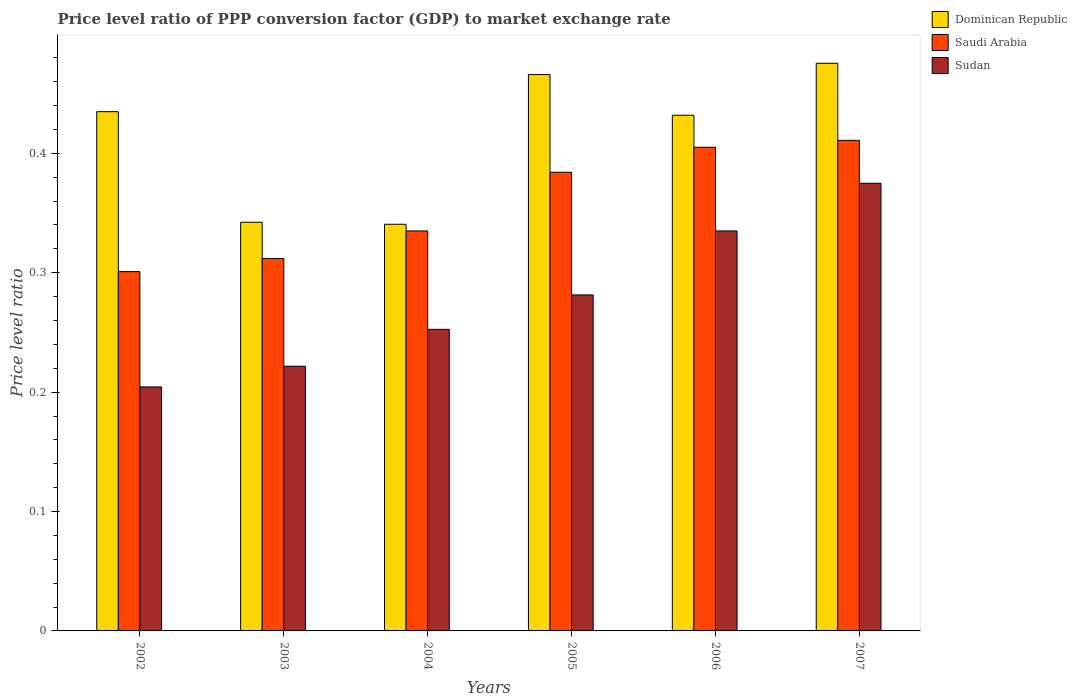How many different coloured bars are there?
Offer a very short reply. 3. Are the number of bars per tick equal to the number of legend labels?
Make the answer very short. Yes. How many bars are there on the 4th tick from the left?
Offer a very short reply. 3. In how many cases, is the number of bars for a given year not equal to the number of legend labels?
Offer a terse response. 0. What is the price level ratio in Saudi Arabia in 2002?
Provide a succinct answer. 0.3. Across all years, what is the maximum price level ratio in Sudan?
Provide a succinct answer. 0.37. Across all years, what is the minimum price level ratio in Saudi Arabia?
Offer a very short reply. 0.3. In which year was the price level ratio in Saudi Arabia maximum?
Your answer should be very brief. 2007. What is the total price level ratio in Dominican Republic in the graph?
Ensure brevity in your answer.  2.49. What is the difference between the price level ratio in Sudan in 2002 and that in 2007?
Offer a very short reply. -0.17. What is the difference between the price level ratio in Saudi Arabia in 2003 and the price level ratio in Sudan in 2006?
Provide a short and direct response. -0.02. What is the average price level ratio in Dominican Republic per year?
Offer a very short reply. 0.42. In the year 2006, what is the difference between the price level ratio in Sudan and price level ratio in Dominican Republic?
Keep it short and to the point. -0.1. In how many years, is the price level ratio in Sudan greater than 0.2?
Your answer should be very brief. 6. What is the ratio of the price level ratio in Sudan in 2005 to that in 2006?
Make the answer very short. 0.84. Is the price level ratio in Saudi Arabia in 2003 less than that in 2006?
Keep it short and to the point. Yes. Is the difference between the price level ratio in Sudan in 2002 and 2005 greater than the difference between the price level ratio in Dominican Republic in 2002 and 2005?
Make the answer very short. No. What is the difference between the highest and the second highest price level ratio in Dominican Republic?
Offer a very short reply. 0.01. What is the difference between the highest and the lowest price level ratio in Saudi Arabia?
Offer a very short reply. 0.11. In how many years, is the price level ratio in Dominican Republic greater than the average price level ratio in Dominican Republic taken over all years?
Ensure brevity in your answer.  4. Is the sum of the price level ratio in Dominican Republic in 2004 and 2005 greater than the maximum price level ratio in Sudan across all years?
Make the answer very short. Yes. What does the 2nd bar from the left in 2003 represents?
Provide a short and direct response. Saudi Arabia. What does the 2nd bar from the right in 2006 represents?
Provide a succinct answer. Saudi Arabia. How many bars are there?
Provide a short and direct response. 18. Are all the bars in the graph horizontal?
Offer a terse response. No. How many years are there in the graph?
Your answer should be very brief. 6. What is the difference between two consecutive major ticks on the Y-axis?
Provide a short and direct response. 0.1. Does the graph contain any zero values?
Provide a succinct answer. No. Does the graph contain grids?
Your answer should be compact. No. Where does the legend appear in the graph?
Provide a succinct answer. Top right. What is the title of the graph?
Provide a succinct answer. Price level ratio of PPP conversion factor (GDP) to market exchange rate. Does "Hong Kong" appear as one of the legend labels in the graph?
Make the answer very short. No. What is the label or title of the Y-axis?
Keep it short and to the point. Price level ratio. What is the Price level ratio in Dominican Republic in 2002?
Offer a terse response. 0.43. What is the Price level ratio of Saudi Arabia in 2002?
Provide a short and direct response. 0.3. What is the Price level ratio in Sudan in 2002?
Your response must be concise. 0.2. What is the Price level ratio of Dominican Republic in 2003?
Offer a terse response. 0.34. What is the Price level ratio in Saudi Arabia in 2003?
Provide a succinct answer. 0.31. What is the Price level ratio in Sudan in 2003?
Keep it short and to the point. 0.22. What is the Price level ratio in Dominican Republic in 2004?
Make the answer very short. 0.34. What is the Price level ratio of Saudi Arabia in 2004?
Your answer should be very brief. 0.34. What is the Price level ratio of Sudan in 2004?
Offer a very short reply. 0.25. What is the Price level ratio of Dominican Republic in 2005?
Give a very brief answer. 0.47. What is the Price level ratio of Saudi Arabia in 2005?
Provide a succinct answer. 0.38. What is the Price level ratio of Sudan in 2005?
Provide a short and direct response. 0.28. What is the Price level ratio in Dominican Republic in 2006?
Make the answer very short. 0.43. What is the Price level ratio in Saudi Arabia in 2006?
Give a very brief answer. 0.41. What is the Price level ratio in Sudan in 2006?
Offer a terse response. 0.34. What is the Price level ratio of Dominican Republic in 2007?
Offer a terse response. 0.48. What is the Price level ratio of Saudi Arabia in 2007?
Provide a succinct answer. 0.41. What is the Price level ratio in Sudan in 2007?
Offer a terse response. 0.37. Across all years, what is the maximum Price level ratio in Dominican Republic?
Ensure brevity in your answer.  0.48. Across all years, what is the maximum Price level ratio of Saudi Arabia?
Make the answer very short. 0.41. Across all years, what is the maximum Price level ratio of Sudan?
Provide a short and direct response. 0.37. Across all years, what is the minimum Price level ratio in Dominican Republic?
Your response must be concise. 0.34. Across all years, what is the minimum Price level ratio in Saudi Arabia?
Keep it short and to the point. 0.3. Across all years, what is the minimum Price level ratio in Sudan?
Your answer should be compact. 0.2. What is the total Price level ratio of Dominican Republic in the graph?
Provide a succinct answer. 2.49. What is the total Price level ratio in Saudi Arabia in the graph?
Provide a succinct answer. 2.15. What is the total Price level ratio of Sudan in the graph?
Offer a terse response. 1.67. What is the difference between the Price level ratio of Dominican Republic in 2002 and that in 2003?
Your answer should be compact. 0.09. What is the difference between the Price level ratio in Saudi Arabia in 2002 and that in 2003?
Offer a terse response. -0.01. What is the difference between the Price level ratio of Sudan in 2002 and that in 2003?
Your answer should be compact. -0.02. What is the difference between the Price level ratio of Dominican Republic in 2002 and that in 2004?
Give a very brief answer. 0.09. What is the difference between the Price level ratio of Saudi Arabia in 2002 and that in 2004?
Your answer should be compact. -0.03. What is the difference between the Price level ratio in Sudan in 2002 and that in 2004?
Keep it short and to the point. -0.05. What is the difference between the Price level ratio of Dominican Republic in 2002 and that in 2005?
Offer a terse response. -0.03. What is the difference between the Price level ratio of Saudi Arabia in 2002 and that in 2005?
Your response must be concise. -0.08. What is the difference between the Price level ratio of Sudan in 2002 and that in 2005?
Offer a terse response. -0.08. What is the difference between the Price level ratio of Dominican Republic in 2002 and that in 2006?
Give a very brief answer. 0. What is the difference between the Price level ratio in Saudi Arabia in 2002 and that in 2006?
Your answer should be compact. -0.1. What is the difference between the Price level ratio of Sudan in 2002 and that in 2006?
Your answer should be very brief. -0.13. What is the difference between the Price level ratio of Dominican Republic in 2002 and that in 2007?
Keep it short and to the point. -0.04. What is the difference between the Price level ratio in Saudi Arabia in 2002 and that in 2007?
Ensure brevity in your answer.  -0.11. What is the difference between the Price level ratio in Sudan in 2002 and that in 2007?
Offer a very short reply. -0.17. What is the difference between the Price level ratio in Dominican Republic in 2003 and that in 2004?
Your answer should be compact. 0. What is the difference between the Price level ratio of Saudi Arabia in 2003 and that in 2004?
Give a very brief answer. -0.02. What is the difference between the Price level ratio in Sudan in 2003 and that in 2004?
Make the answer very short. -0.03. What is the difference between the Price level ratio in Dominican Republic in 2003 and that in 2005?
Give a very brief answer. -0.12. What is the difference between the Price level ratio of Saudi Arabia in 2003 and that in 2005?
Provide a short and direct response. -0.07. What is the difference between the Price level ratio in Sudan in 2003 and that in 2005?
Give a very brief answer. -0.06. What is the difference between the Price level ratio of Dominican Republic in 2003 and that in 2006?
Your answer should be very brief. -0.09. What is the difference between the Price level ratio in Saudi Arabia in 2003 and that in 2006?
Your response must be concise. -0.09. What is the difference between the Price level ratio of Sudan in 2003 and that in 2006?
Provide a short and direct response. -0.11. What is the difference between the Price level ratio in Dominican Republic in 2003 and that in 2007?
Make the answer very short. -0.13. What is the difference between the Price level ratio in Saudi Arabia in 2003 and that in 2007?
Your answer should be compact. -0.1. What is the difference between the Price level ratio of Sudan in 2003 and that in 2007?
Offer a very short reply. -0.15. What is the difference between the Price level ratio in Dominican Republic in 2004 and that in 2005?
Your response must be concise. -0.13. What is the difference between the Price level ratio in Saudi Arabia in 2004 and that in 2005?
Provide a short and direct response. -0.05. What is the difference between the Price level ratio in Sudan in 2004 and that in 2005?
Keep it short and to the point. -0.03. What is the difference between the Price level ratio in Dominican Republic in 2004 and that in 2006?
Give a very brief answer. -0.09. What is the difference between the Price level ratio of Saudi Arabia in 2004 and that in 2006?
Ensure brevity in your answer.  -0.07. What is the difference between the Price level ratio of Sudan in 2004 and that in 2006?
Give a very brief answer. -0.08. What is the difference between the Price level ratio of Dominican Republic in 2004 and that in 2007?
Offer a very short reply. -0.13. What is the difference between the Price level ratio of Saudi Arabia in 2004 and that in 2007?
Provide a short and direct response. -0.08. What is the difference between the Price level ratio in Sudan in 2004 and that in 2007?
Your answer should be very brief. -0.12. What is the difference between the Price level ratio in Dominican Republic in 2005 and that in 2006?
Ensure brevity in your answer.  0.03. What is the difference between the Price level ratio of Saudi Arabia in 2005 and that in 2006?
Your response must be concise. -0.02. What is the difference between the Price level ratio in Sudan in 2005 and that in 2006?
Your answer should be very brief. -0.05. What is the difference between the Price level ratio in Dominican Republic in 2005 and that in 2007?
Offer a very short reply. -0.01. What is the difference between the Price level ratio of Saudi Arabia in 2005 and that in 2007?
Your response must be concise. -0.03. What is the difference between the Price level ratio of Sudan in 2005 and that in 2007?
Give a very brief answer. -0.09. What is the difference between the Price level ratio of Dominican Republic in 2006 and that in 2007?
Make the answer very short. -0.04. What is the difference between the Price level ratio in Saudi Arabia in 2006 and that in 2007?
Keep it short and to the point. -0.01. What is the difference between the Price level ratio of Sudan in 2006 and that in 2007?
Your answer should be very brief. -0.04. What is the difference between the Price level ratio in Dominican Republic in 2002 and the Price level ratio in Saudi Arabia in 2003?
Your response must be concise. 0.12. What is the difference between the Price level ratio in Dominican Republic in 2002 and the Price level ratio in Sudan in 2003?
Keep it short and to the point. 0.21. What is the difference between the Price level ratio in Saudi Arabia in 2002 and the Price level ratio in Sudan in 2003?
Your answer should be compact. 0.08. What is the difference between the Price level ratio in Dominican Republic in 2002 and the Price level ratio in Saudi Arabia in 2004?
Your answer should be compact. 0.1. What is the difference between the Price level ratio in Dominican Republic in 2002 and the Price level ratio in Sudan in 2004?
Provide a short and direct response. 0.18. What is the difference between the Price level ratio in Saudi Arabia in 2002 and the Price level ratio in Sudan in 2004?
Offer a very short reply. 0.05. What is the difference between the Price level ratio of Dominican Republic in 2002 and the Price level ratio of Saudi Arabia in 2005?
Give a very brief answer. 0.05. What is the difference between the Price level ratio in Dominican Republic in 2002 and the Price level ratio in Sudan in 2005?
Ensure brevity in your answer.  0.15. What is the difference between the Price level ratio of Saudi Arabia in 2002 and the Price level ratio of Sudan in 2005?
Make the answer very short. 0.02. What is the difference between the Price level ratio of Dominican Republic in 2002 and the Price level ratio of Saudi Arabia in 2006?
Your answer should be very brief. 0.03. What is the difference between the Price level ratio in Dominican Republic in 2002 and the Price level ratio in Sudan in 2006?
Ensure brevity in your answer.  0.1. What is the difference between the Price level ratio of Saudi Arabia in 2002 and the Price level ratio of Sudan in 2006?
Your response must be concise. -0.03. What is the difference between the Price level ratio in Dominican Republic in 2002 and the Price level ratio in Saudi Arabia in 2007?
Your answer should be very brief. 0.02. What is the difference between the Price level ratio in Saudi Arabia in 2002 and the Price level ratio in Sudan in 2007?
Offer a very short reply. -0.07. What is the difference between the Price level ratio of Dominican Republic in 2003 and the Price level ratio of Saudi Arabia in 2004?
Keep it short and to the point. 0.01. What is the difference between the Price level ratio in Dominican Republic in 2003 and the Price level ratio in Sudan in 2004?
Provide a short and direct response. 0.09. What is the difference between the Price level ratio in Saudi Arabia in 2003 and the Price level ratio in Sudan in 2004?
Ensure brevity in your answer.  0.06. What is the difference between the Price level ratio of Dominican Republic in 2003 and the Price level ratio of Saudi Arabia in 2005?
Provide a short and direct response. -0.04. What is the difference between the Price level ratio in Dominican Republic in 2003 and the Price level ratio in Sudan in 2005?
Make the answer very short. 0.06. What is the difference between the Price level ratio of Saudi Arabia in 2003 and the Price level ratio of Sudan in 2005?
Keep it short and to the point. 0.03. What is the difference between the Price level ratio in Dominican Republic in 2003 and the Price level ratio in Saudi Arabia in 2006?
Make the answer very short. -0.06. What is the difference between the Price level ratio of Dominican Republic in 2003 and the Price level ratio of Sudan in 2006?
Provide a succinct answer. 0.01. What is the difference between the Price level ratio in Saudi Arabia in 2003 and the Price level ratio in Sudan in 2006?
Provide a succinct answer. -0.02. What is the difference between the Price level ratio in Dominican Republic in 2003 and the Price level ratio in Saudi Arabia in 2007?
Ensure brevity in your answer.  -0.07. What is the difference between the Price level ratio of Dominican Republic in 2003 and the Price level ratio of Sudan in 2007?
Your answer should be very brief. -0.03. What is the difference between the Price level ratio of Saudi Arabia in 2003 and the Price level ratio of Sudan in 2007?
Make the answer very short. -0.06. What is the difference between the Price level ratio in Dominican Republic in 2004 and the Price level ratio in Saudi Arabia in 2005?
Provide a succinct answer. -0.04. What is the difference between the Price level ratio in Dominican Republic in 2004 and the Price level ratio in Sudan in 2005?
Your answer should be compact. 0.06. What is the difference between the Price level ratio in Saudi Arabia in 2004 and the Price level ratio in Sudan in 2005?
Offer a very short reply. 0.05. What is the difference between the Price level ratio in Dominican Republic in 2004 and the Price level ratio in Saudi Arabia in 2006?
Give a very brief answer. -0.06. What is the difference between the Price level ratio in Dominican Republic in 2004 and the Price level ratio in Sudan in 2006?
Your response must be concise. 0.01. What is the difference between the Price level ratio of Saudi Arabia in 2004 and the Price level ratio of Sudan in 2006?
Keep it short and to the point. 0. What is the difference between the Price level ratio in Dominican Republic in 2004 and the Price level ratio in Saudi Arabia in 2007?
Offer a very short reply. -0.07. What is the difference between the Price level ratio in Dominican Republic in 2004 and the Price level ratio in Sudan in 2007?
Your answer should be very brief. -0.03. What is the difference between the Price level ratio of Saudi Arabia in 2004 and the Price level ratio of Sudan in 2007?
Provide a succinct answer. -0.04. What is the difference between the Price level ratio in Dominican Republic in 2005 and the Price level ratio in Saudi Arabia in 2006?
Make the answer very short. 0.06. What is the difference between the Price level ratio in Dominican Republic in 2005 and the Price level ratio in Sudan in 2006?
Provide a succinct answer. 0.13. What is the difference between the Price level ratio in Saudi Arabia in 2005 and the Price level ratio in Sudan in 2006?
Give a very brief answer. 0.05. What is the difference between the Price level ratio in Dominican Republic in 2005 and the Price level ratio in Saudi Arabia in 2007?
Your answer should be compact. 0.06. What is the difference between the Price level ratio in Dominican Republic in 2005 and the Price level ratio in Sudan in 2007?
Offer a very short reply. 0.09. What is the difference between the Price level ratio in Saudi Arabia in 2005 and the Price level ratio in Sudan in 2007?
Your answer should be compact. 0.01. What is the difference between the Price level ratio of Dominican Republic in 2006 and the Price level ratio of Saudi Arabia in 2007?
Your answer should be compact. 0.02. What is the difference between the Price level ratio of Dominican Republic in 2006 and the Price level ratio of Sudan in 2007?
Your answer should be compact. 0.06. What is the difference between the Price level ratio of Saudi Arabia in 2006 and the Price level ratio of Sudan in 2007?
Provide a succinct answer. 0.03. What is the average Price level ratio of Dominican Republic per year?
Your answer should be compact. 0.42. What is the average Price level ratio of Saudi Arabia per year?
Ensure brevity in your answer.  0.36. What is the average Price level ratio in Sudan per year?
Give a very brief answer. 0.28. In the year 2002, what is the difference between the Price level ratio of Dominican Republic and Price level ratio of Saudi Arabia?
Make the answer very short. 0.13. In the year 2002, what is the difference between the Price level ratio in Dominican Republic and Price level ratio in Sudan?
Your answer should be very brief. 0.23. In the year 2002, what is the difference between the Price level ratio of Saudi Arabia and Price level ratio of Sudan?
Give a very brief answer. 0.1. In the year 2003, what is the difference between the Price level ratio of Dominican Republic and Price level ratio of Saudi Arabia?
Offer a terse response. 0.03. In the year 2003, what is the difference between the Price level ratio in Dominican Republic and Price level ratio in Sudan?
Keep it short and to the point. 0.12. In the year 2003, what is the difference between the Price level ratio of Saudi Arabia and Price level ratio of Sudan?
Keep it short and to the point. 0.09. In the year 2004, what is the difference between the Price level ratio of Dominican Republic and Price level ratio of Saudi Arabia?
Your answer should be compact. 0.01. In the year 2004, what is the difference between the Price level ratio in Dominican Republic and Price level ratio in Sudan?
Ensure brevity in your answer.  0.09. In the year 2004, what is the difference between the Price level ratio of Saudi Arabia and Price level ratio of Sudan?
Provide a short and direct response. 0.08. In the year 2005, what is the difference between the Price level ratio of Dominican Republic and Price level ratio of Saudi Arabia?
Offer a very short reply. 0.08. In the year 2005, what is the difference between the Price level ratio in Dominican Republic and Price level ratio in Sudan?
Provide a succinct answer. 0.18. In the year 2005, what is the difference between the Price level ratio of Saudi Arabia and Price level ratio of Sudan?
Offer a very short reply. 0.1. In the year 2006, what is the difference between the Price level ratio of Dominican Republic and Price level ratio of Saudi Arabia?
Offer a very short reply. 0.03. In the year 2006, what is the difference between the Price level ratio of Dominican Republic and Price level ratio of Sudan?
Provide a short and direct response. 0.1. In the year 2006, what is the difference between the Price level ratio in Saudi Arabia and Price level ratio in Sudan?
Ensure brevity in your answer.  0.07. In the year 2007, what is the difference between the Price level ratio in Dominican Republic and Price level ratio in Saudi Arabia?
Make the answer very short. 0.06. In the year 2007, what is the difference between the Price level ratio of Dominican Republic and Price level ratio of Sudan?
Your response must be concise. 0.1. In the year 2007, what is the difference between the Price level ratio in Saudi Arabia and Price level ratio in Sudan?
Your answer should be very brief. 0.04. What is the ratio of the Price level ratio of Dominican Republic in 2002 to that in 2003?
Provide a short and direct response. 1.27. What is the ratio of the Price level ratio in Saudi Arabia in 2002 to that in 2003?
Offer a very short reply. 0.96. What is the ratio of the Price level ratio of Sudan in 2002 to that in 2003?
Provide a succinct answer. 0.92. What is the ratio of the Price level ratio in Dominican Republic in 2002 to that in 2004?
Keep it short and to the point. 1.28. What is the ratio of the Price level ratio in Saudi Arabia in 2002 to that in 2004?
Your response must be concise. 0.9. What is the ratio of the Price level ratio in Sudan in 2002 to that in 2004?
Offer a very short reply. 0.81. What is the ratio of the Price level ratio of Saudi Arabia in 2002 to that in 2005?
Your response must be concise. 0.78. What is the ratio of the Price level ratio of Sudan in 2002 to that in 2005?
Your response must be concise. 0.73. What is the ratio of the Price level ratio of Dominican Republic in 2002 to that in 2006?
Provide a short and direct response. 1.01. What is the ratio of the Price level ratio of Saudi Arabia in 2002 to that in 2006?
Ensure brevity in your answer.  0.74. What is the ratio of the Price level ratio in Sudan in 2002 to that in 2006?
Offer a terse response. 0.61. What is the ratio of the Price level ratio in Dominican Republic in 2002 to that in 2007?
Provide a succinct answer. 0.91. What is the ratio of the Price level ratio in Saudi Arabia in 2002 to that in 2007?
Offer a terse response. 0.73. What is the ratio of the Price level ratio of Sudan in 2002 to that in 2007?
Provide a succinct answer. 0.55. What is the ratio of the Price level ratio of Dominican Republic in 2003 to that in 2004?
Offer a terse response. 1. What is the ratio of the Price level ratio of Saudi Arabia in 2003 to that in 2004?
Make the answer very short. 0.93. What is the ratio of the Price level ratio of Sudan in 2003 to that in 2004?
Offer a very short reply. 0.88. What is the ratio of the Price level ratio in Dominican Republic in 2003 to that in 2005?
Provide a succinct answer. 0.73. What is the ratio of the Price level ratio in Saudi Arabia in 2003 to that in 2005?
Ensure brevity in your answer.  0.81. What is the ratio of the Price level ratio of Sudan in 2003 to that in 2005?
Provide a succinct answer. 0.79. What is the ratio of the Price level ratio in Dominican Republic in 2003 to that in 2006?
Offer a very short reply. 0.79. What is the ratio of the Price level ratio in Saudi Arabia in 2003 to that in 2006?
Your answer should be very brief. 0.77. What is the ratio of the Price level ratio in Sudan in 2003 to that in 2006?
Provide a succinct answer. 0.66. What is the ratio of the Price level ratio of Dominican Republic in 2003 to that in 2007?
Provide a short and direct response. 0.72. What is the ratio of the Price level ratio in Saudi Arabia in 2003 to that in 2007?
Provide a short and direct response. 0.76. What is the ratio of the Price level ratio of Sudan in 2003 to that in 2007?
Make the answer very short. 0.59. What is the ratio of the Price level ratio of Dominican Republic in 2004 to that in 2005?
Offer a very short reply. 0.73. What is the ratio of the Price level ratio of Saudi Arabia in 2004 to that in 2005?
Give a very brief answer. 0.87. What is the ratio of the Price level ratio of Sudan in 2004 to that in 2005?
Your answer should be very brief. 0.9. What is the ratio of the Price level ratio in Dominican Republic in 2004 to that in 2006?
Give a very brief answer. 0.79. What is the ratio of the Price level ratio of Saudi Arabia in 2004 to that in 2006?
Offer a terse response. 0.83. What is the ratio of the Price level ratio of Sudan in 2004 to that in 2006?
Offer a terse response. 0.75. What is the ratio of the Price level ratio of Dominican Republic in 2004 to that in 2007?
Give a very brief answer. 0.72. What is the ratio of the Price level ratio in Saudi Arabia in 2004 to that in 2007?
Ensure brevity in your answer.  0.82. What is the ratio of the Price level ratio in Sudan in 2004 to that in 2007?
Offer a very short reply. 0.67. What is the ratio of the Price level ratio of Dominican Republic in 2005 to that in 2006?
Give a very brief answer. 1.08. What is the ratio of the Price level ratio of Saudi Arabia in 2005 to that in 2006?
Your answer should be very brief. 0.95. What is the ratio of the Price level ratio of Sudan in 2005 to that in 2006?
Give a very brief answer. 0.84. What is the ratio of the Price level ratio of Dominican Republic in 2005 to that in 2007?
Give a very brief answer. 0.98. What is the ratio of the Price level ratio in Saudi Arabia in 2005 to that in 2007?
Make the answer very short. 0.94. What is the ratio of the Price level ratio in Sudan in 2005 to that in 2007?
Your answer should be compact. 0.75. What is the ratio of the Price level ratio of Dominican Republic in 2006 to that in 2007?
Offer a terse response. 0.91. What is the ratio of the Price level ratio of Saudi Arabia in 2006 to that in 2007?
Keep it short and to the point. 0.99. What is the ratio of the Price level ratio in Sudan in 2006 to that in 2007?
Ensure brevity in your answer.  0.89. What is the difference between the highest and the second highest Price level ratio of Dominican Republic?
Provide a short and direct response. 0.01. What is the difference between the highest and the second highest Price level ratio in Saudi Arabia?
Your response must be concise. 0.01. What is the difference between the highest and the second highest Price level ratio of Sudan?
Offer a terse response. 0.04. What is the difference between the highest and the lowest Price level ratio of Dominican Republic?
Offer a very short reply. 0.13. What is the difference between the highest and the lowest Price level ratio in Saudi Arabia?
Offer a terse response. 0.11. What is the difference between the highest and the lowest Price level ratio of Sudan?
Ensure brevity in your answer.  0.17. 